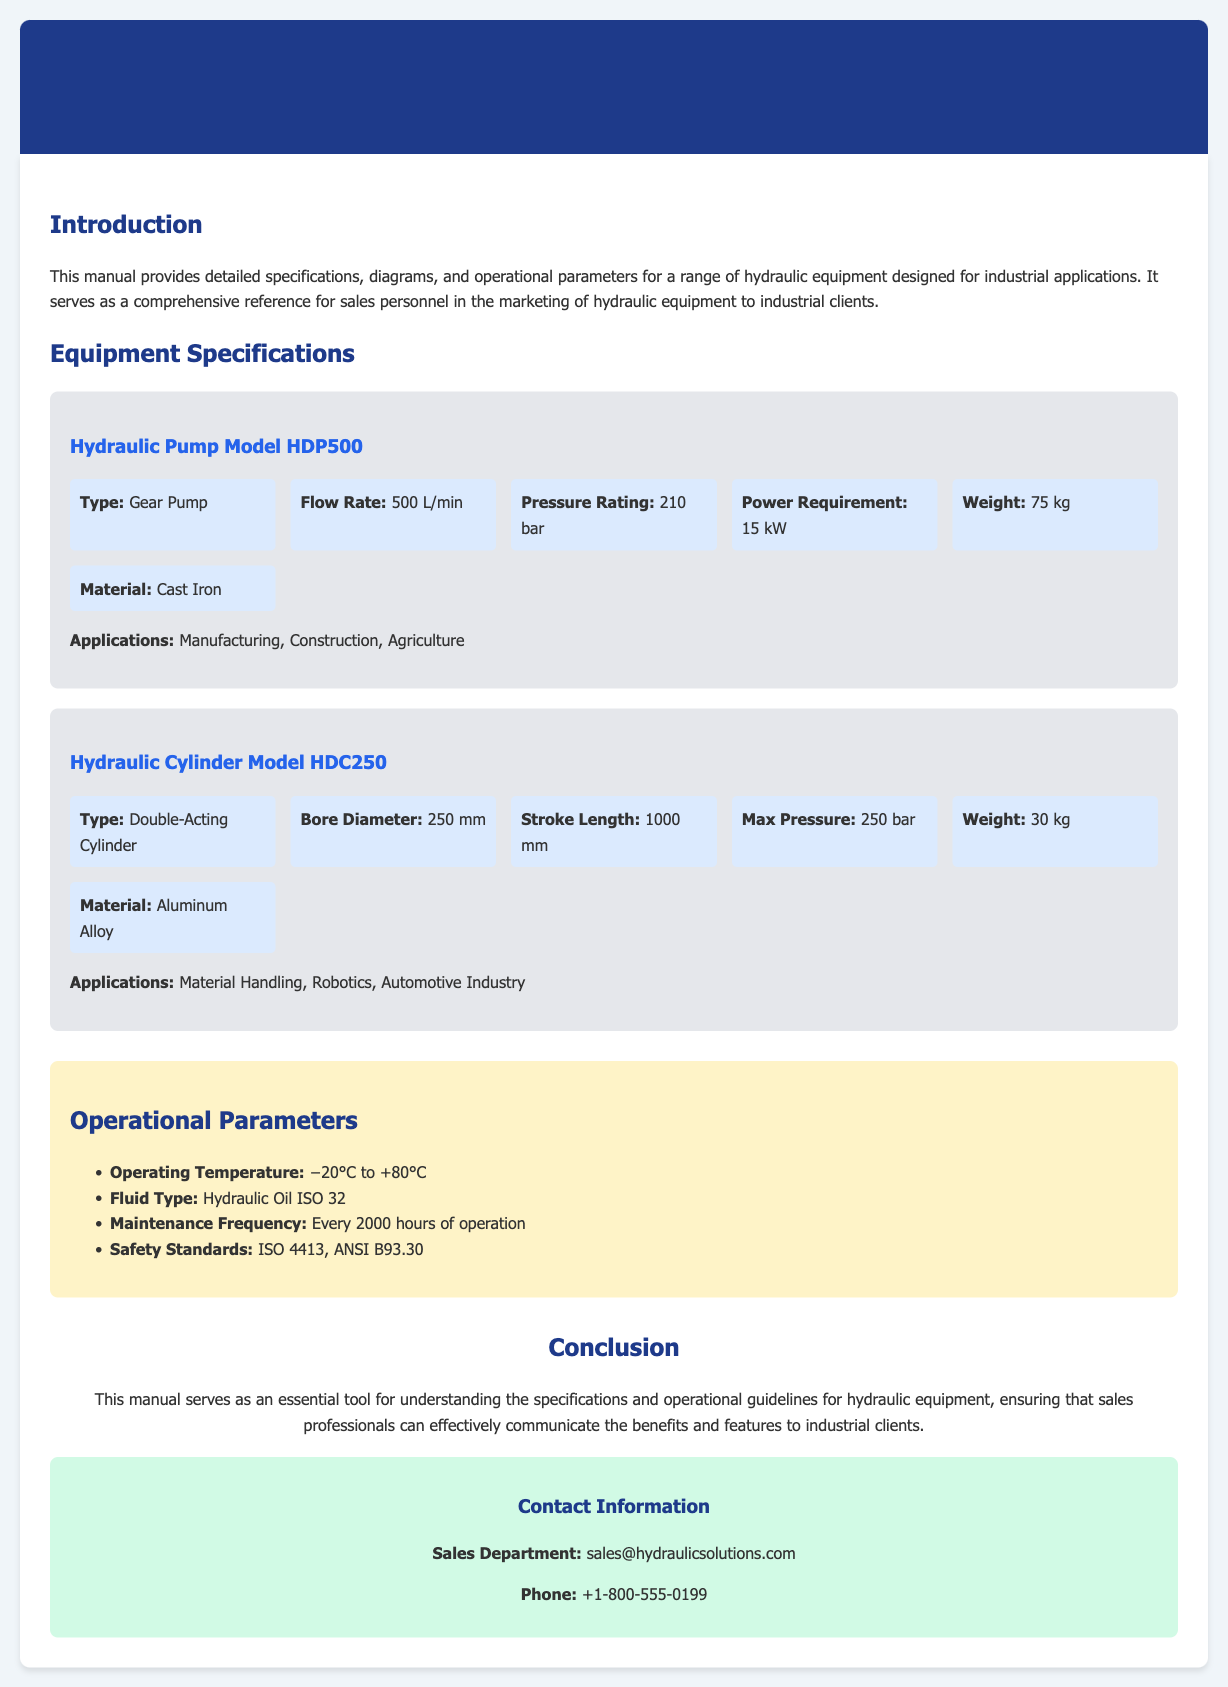What is the flow rate of the Hydraulic Pump Model HDP500? The flow rate is specified under the hydraulic pump section, which lists it as 500 L/min.
Answer: 500 L/min What is the maximum pressure for the Hydraulic Cylinder Model HDC250? The maximum pressure is provided in the specifications for the hydraulic cylinder, listed as 250 bar.
Answer: 250 bar What is the power requirement for the Hydraulic Pump Model HDP500? The power requirement is included in the pump's specifications, showing it as 15 kW.
Answer: 15 kW What material is the Hydraulic Cylinder Model HDC250 made of? The cylinder's material is indicated in the specifications as Aluminum Alloy.
Answer: Aluminum Alloy What is the maintenance frequency recommended for the hydraulic equipment? The recommended maintenance frequency is noted in the operational parameters section, listed as every 2000 hours of operation.
Answer: Every 2000 hours Which hydraulic oil type is specified for use? The type of hydraulic oil is mentioned in the operational parameters section as Hydraulic Oil ISO 32.
Answer: Hydraulic Oil ISO 32 What are the applications for the Hydraulic Pump Model HDP500? The applications are specified in the pump's specifications and listed as Manufacturing, Construction, Agriculture.
Answer: Manufacturing, Construction, Agriculture What safety standards are referenced in the manual? The safety standards are outlined in the operational parameters, stated as ISO 4413, ANSI B93.30.
Answer: ISO 4413, ANSI B93.30 